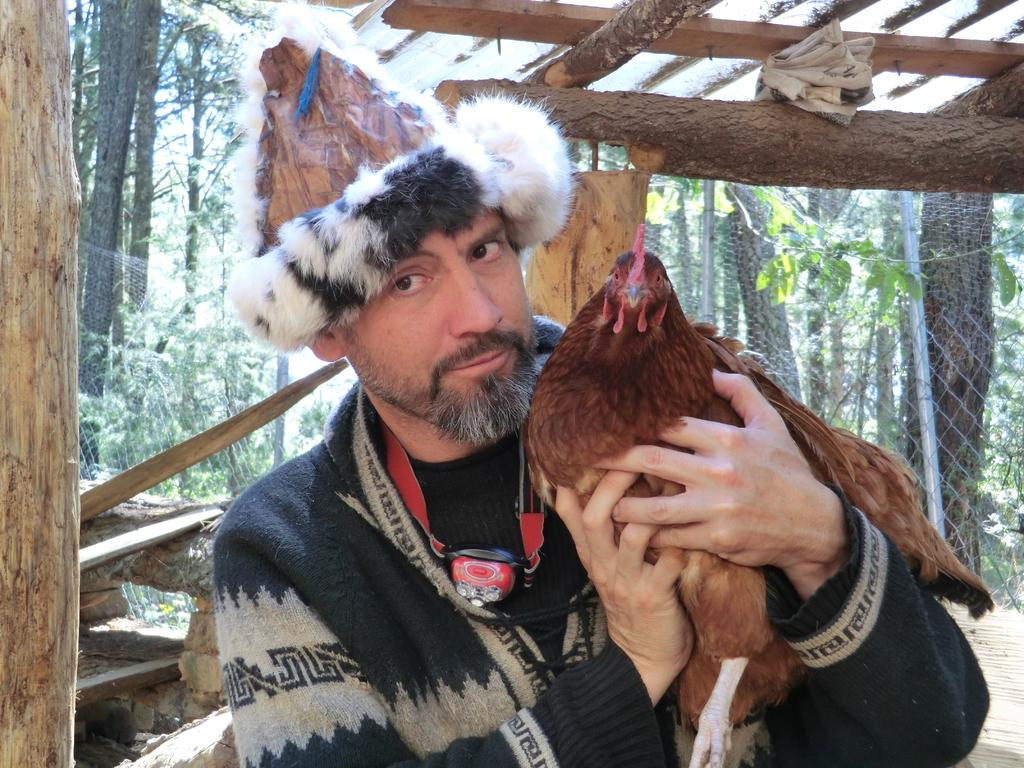What can be seen in the image? There is a person in the image. Can you describe the person's attire? The person is wearing a hat. What is the person holding in the image? The person is holding a hen. What can be seen in the background of the image? There are branches, a mesh, a pole, and trees in the background of the image. What type of clam can be seen in the image? There is no clam present in the image. How many yams are visible in the image? There are no yams present in the image. 